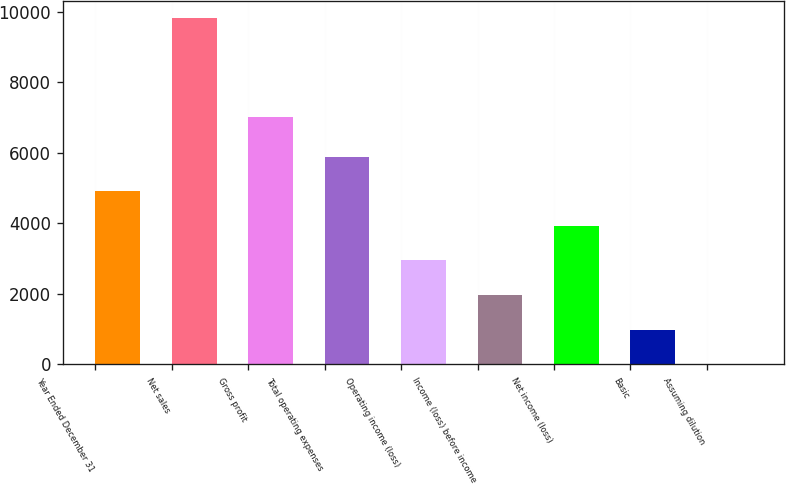Convert chart to OTSL. <chart><loc_0><loc_0><loc_500><loc_500><bar_chart><fcel>Year Ended December 31<fcel>Net sales<fcel>Gross profit<fcel>Total operating expenses<fcel>Operating income (loss)<fcel>Income (loss) before income<fcel>Net income (loss)<fcel>Basic<fcel>Assuming dilution<nl><fcel>4912.09<fcel>9823<fcel>7011<fcel>5894.27<fcel>2947.73<fcel>1965.55<fcel>3929.91<fcel>983.37<fcel>1.19<nl></chart> 